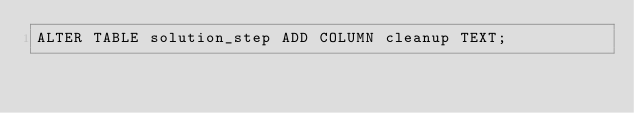Convert code to text. <code><loc_0><loc_0><loc_500><loc_500><_SQL_>ALTER TABLE solution_step ADD COLUMN cleanup TEXT;
</code> 